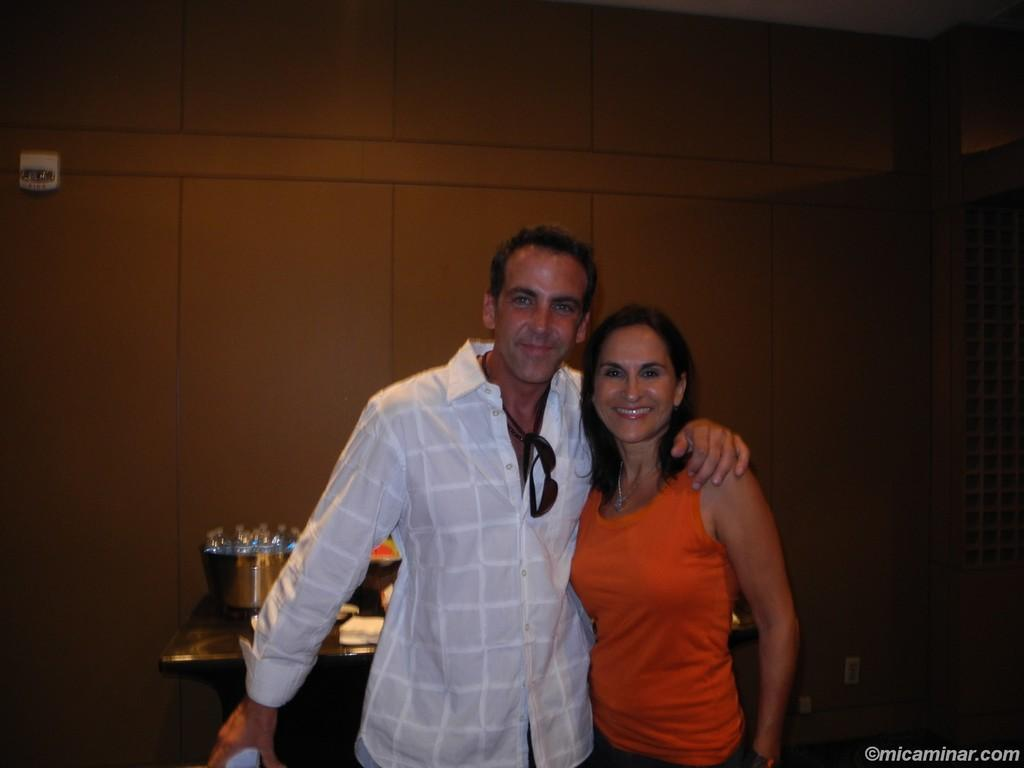Who can be seen in the image? There is a lady and a man in the image. What is the man wearing in the image? The man is wearing sunglasses in the image. What can be found on a surface in the image? There are objects on a table in the image. What is visible in the background of the image? There is a wall visible in the image. What type of hat is the lady wearing in the image? There is no hat visible on the lady in the image. What day of the week is it in the image? The day of the week cannot be determined from the image. 